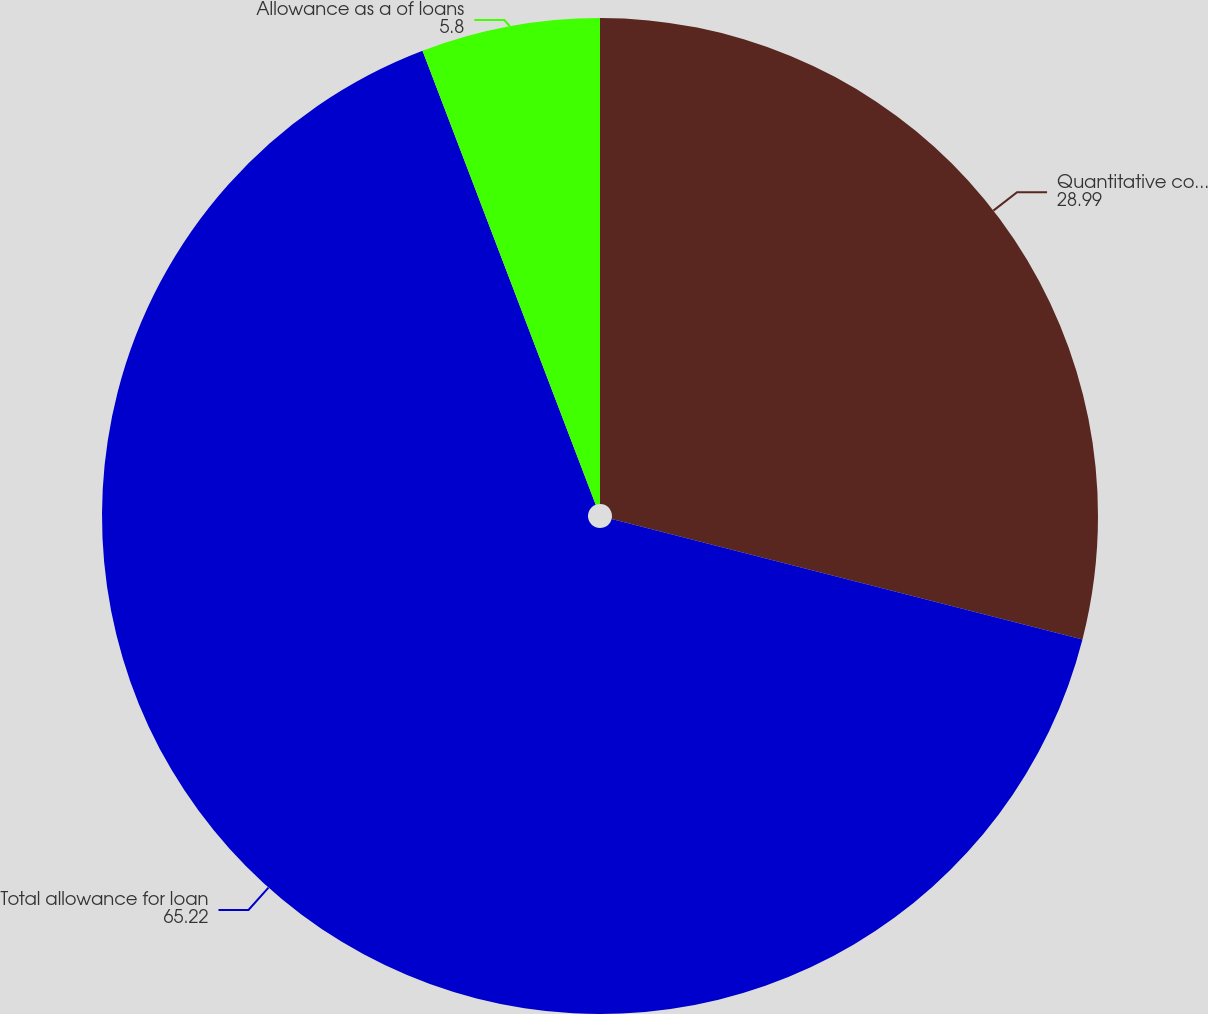<chart> <loc_0><loc_0><loc_500><loc_500><pie_chart><fcel>Quantitative component<fcel>Total allowance for loan<fcel>Allowance as a of loans<nl><fcel>28.99%<fcel>65.22%<fcel>5.8%<nl></chart> 